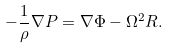Convert formula to latex. <formula><loc_0><loc_0><loc_500><loc_500>- \frac { 1 } { \rho } \nabla P = \nabla \Phi - \Omega ^ { 2 } { R } .</formula> 